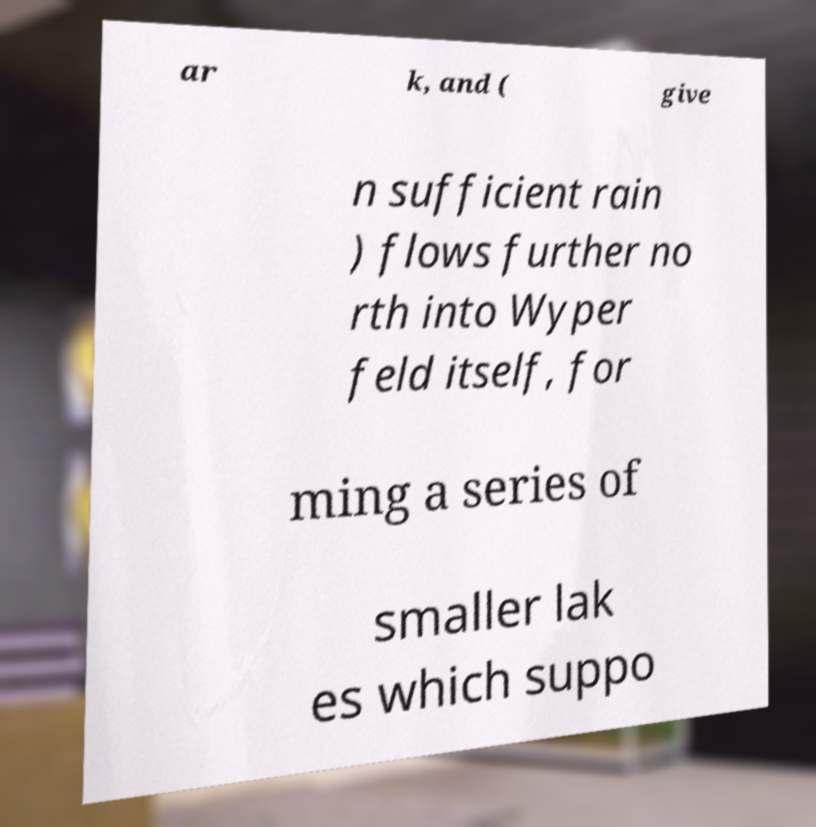Could you assist in decoding the text presented in this image and type it out clearly? ar k, and ( give n sufficient rain ) flows further no rth into Wyper feld itself, for ming a series of smaller lak es which suppo 